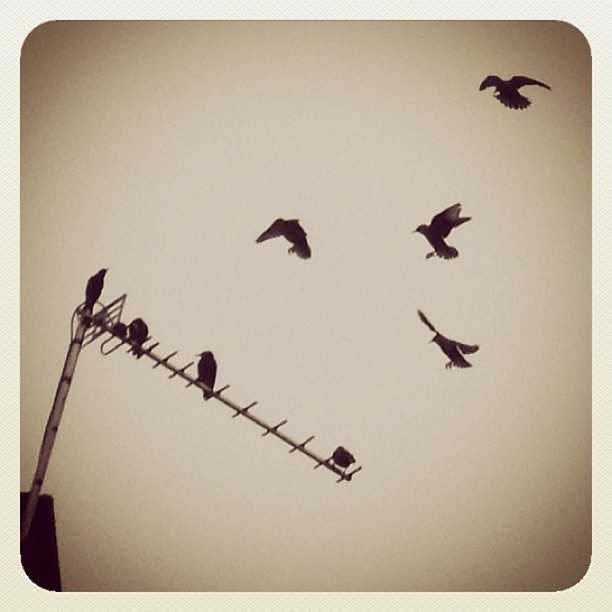Describe the objects in this image and their specific colors. I can see bird in ivory, black, brown, and darkgray tones, bird in ivory, black, gray, and darkgray tones, bird in ivory, black, maroon, tan, and gray tones, bird in ivory, black, gray, and darkgray tones, and bird in ivory, black, maroon, brown, and tan tones in this image. 